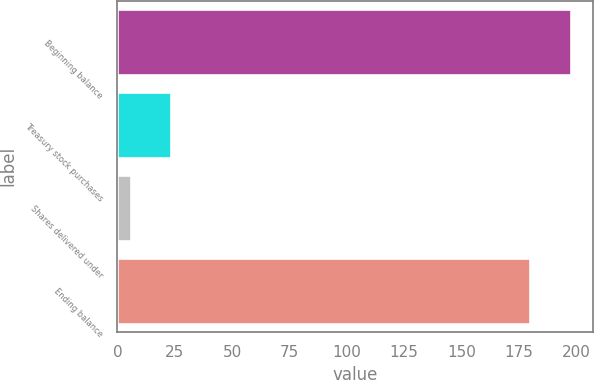Convert chart. <chart><loc_0><loc_0><loc_500><loc_500><bar_chart><fcel>Beginning balance<fcel>Treasury stock purchases<fcel>Shares delivered under<fcel>Ending balance<nl><fcel>197.51<fcel>23.51<fcel>5.7<fcel>179.7<nl></chart> 